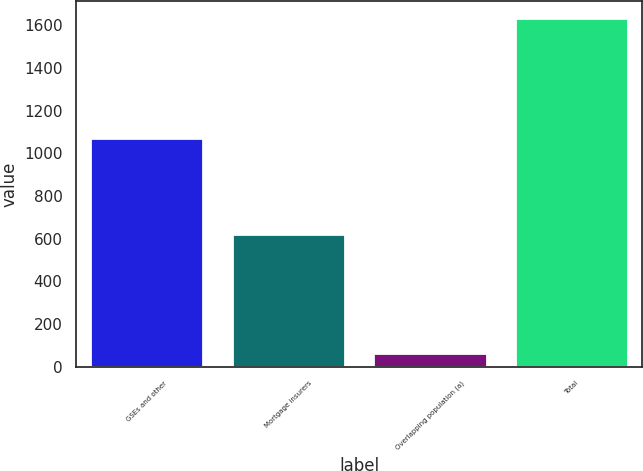Convert chart to OTSL. <chart><loc_0><loc_0><loc_500><loc_500><bar_chart><fcel>GSEs and other<fcel>Mortgage insurers<fcel>Overlapping population (a)<fcel>Total<nl><fcel>1071<fcel>624<fcel>63<fcel>1632<nl></chart> 